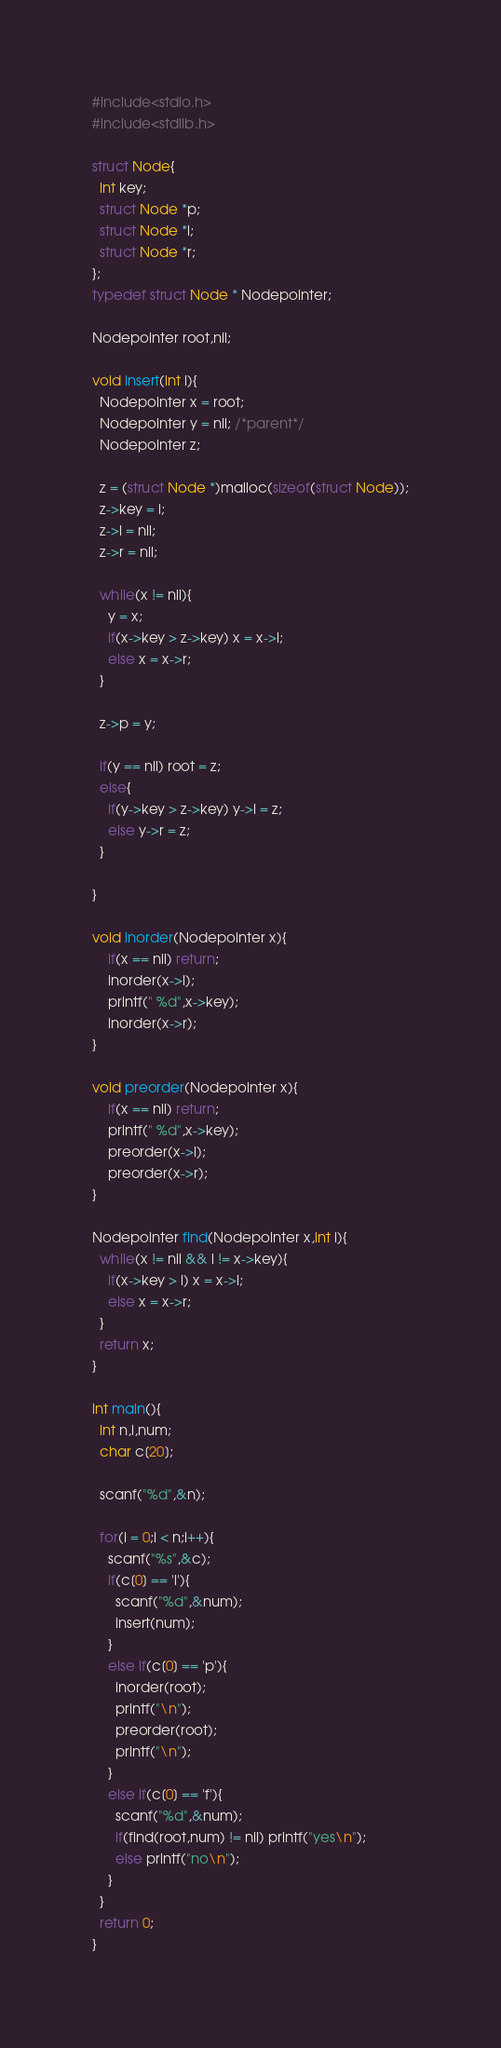Convert code to text. <code><loc_0><loc_0><loc_500><loc_500><_C_>#include<stdio.h>
#include<stdlib.h>

struct Node{
  int key;
  struct Node *p;
  struct Node *l;
  struct Node *r;
};
typedef struct Node * Nodepointer;

Nodepointer root,nil;

void insert(int i){
  Nodepointer x = root;
  Nodepointer y = nil; /*parent*/
  Nodepointer z;

  z = (struct Node *)malloc(sizeof(struct Node));
  z->key = i;
  z->l = nil;
  z->r = nil;

  while(x != nil){
    y = x;
    if(x->key > z->key) x = x->l;
    else x = x->r;
  }

  z->p = y;

  if(y == nil) root = z;
  else{
    if(y->key > z->key) y->l = z;
    else y->r = z;
  }

}

void inorder(Nodepointer x){
    if(x == nil) return;
    inorder(x->l);
    printf(" %d",x->key);
    inorder(x->r);
}

void preorder(Nodepointer x){
    if(x == nil) return;
    printf(" %d",x->key);
    preorder(x->l);
    preorder(x->r);
}

Nodepointer find(Nodepointer x,int i){
  while(x != nil && i != x->key){
    if(x->key > i) x = x->l;
    else x = x->r;
  }
  return x;
}

int main(){
  int n,i,num;
  char c[20];

  scanf("%d",&n);

  for(i = 0;i < n;i++){
    scanf("%s",&c);
    if(c[0] == 'i'){
      scanf("%d",&num);
      insert(num);
    }
    else if(c[0] == 'p'){
      inorder(root);
      printf("\n");
      preorder(root);
      printf("\n");
    }
    else if(c[0] == 'f'){
      scanf("%d",&num);
      if(find(root,num) != nil) printf("yes\n");
      else printf("no\n");
    }
  }
  return 0;
}


</code> 